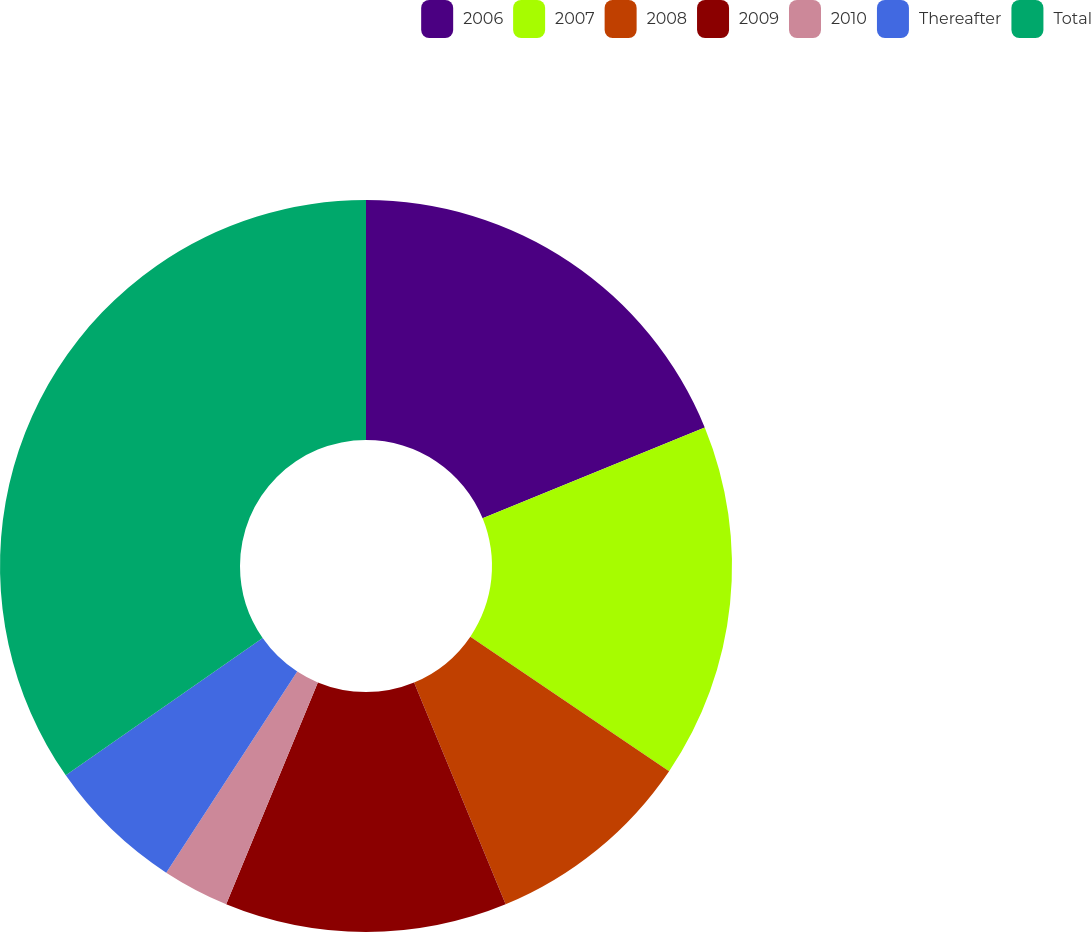<chart> <loc_0><loc_0><loc_500><loc_500><pie_chart><fcel>2006<fcel>2007<fcel>2008<fcel>2009<fcel>2010<fcel>Thereafter<fcel>Total<nl><fcel>18.82%<fcel>15.65%<fcel>9.3%<fcel>12.47%<fcel>2.95%<fcel>6.12%<fcel>34.69%<nl></chart> 